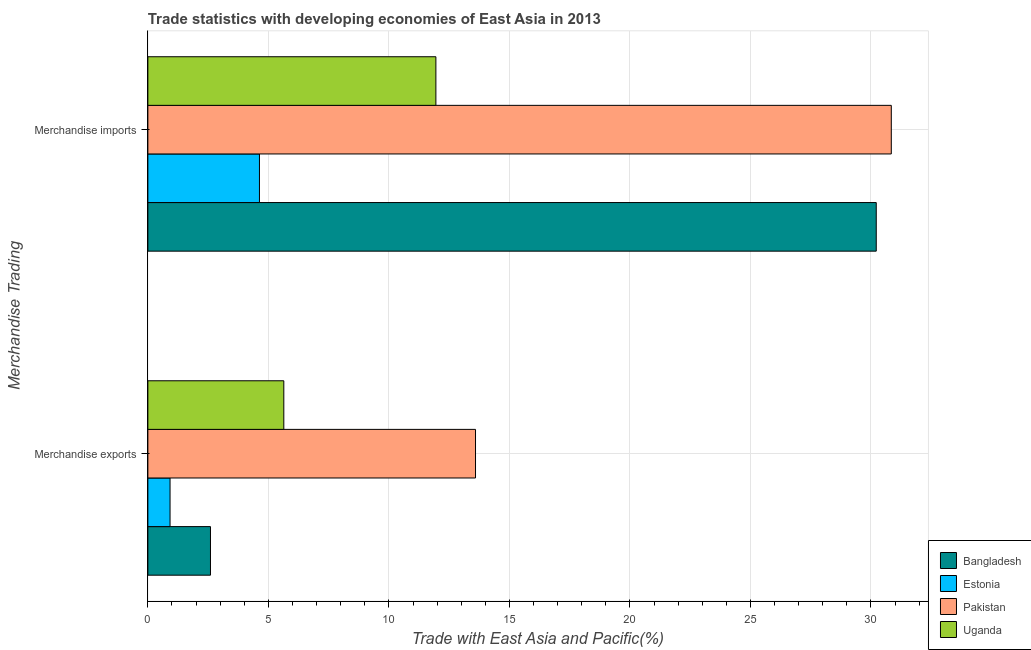How many different coloured bars are there?
Provide a succinct answer. 4. Are the number of bars per tick equal to the number of legend labels?
Ensure brevity in your answer.  Yes. How many bars are there on the 1st tick from the bottom?
Offer a terse response. 4. What is the label of the 1st group of bars from the top?
Make the answer very short. Merchandise imports. What is the merchandise imports in Pakistan?
Your answer should be very brief. 30.84. Across all countries, what is the maximum merchandise imports?
Provide a short and direct response. 30.84. Across all countries, what is the minimum merchandise imports?
Offer a terse response. 4.63. In which country was the merchandise exports minimum?
Ensure brevity in your answer.  Estonia. What is the total merchandise exports in the graph?
Make the answer very short. 22.75. What is the difference between the merchandise imports in Estonia and that in Pakistan?
Your response must be concise. -26.21. What is the difference between the merchandise exports in Uganda and the merchandise imports in Estonia?
Offer a terse response. 1.01. What is the average merchandise exports per country?
Give a very brief answer. 5.69. What is the difference between the merchandise imports and merchandise exports in Pakistan?
Your answer should be compact. 17.25. In how many countries, is the merchandise imports greater than 7 %?
Provide a short and direct response. 3. What is the ratio of the merchandise imports in Uganda to that in Bangladesh?
Ensure brevity in your answer.  0.4. What does the 2nd bar from the bottom in Merchandise imports represents?
Give a very brief answer. Estonia. How many bars are there?
Provide a short and direct response. 8. How many countries are there in the graph?
Make the answer very short. 4. What is the difference between two consecutive major ticks on the X-axis?
Your answer should be compact. 5. Are the values on the major ticks of X-axis written in scientific E-notation?
Offer a very short reply. No. Does the graph contain grids?
Offer a very short reply. Yes. What is the title of the graph?
Offer a terse response. Trade statistics with developing economies of East Asia in 2013. Does "Virgin Islands" appear as one of the legend labels in the graph?
Provide a short and direct response. No. What is the label or title of the X-axis?
Give a very brief answer. Trade with East Asia and Pacific(%). What is the label or title of the Y-axis?
Give a very brief answer. Merchandise Trading. What is the Trade with East Asia and Pacific(%) in Bangladesh in Merchandise exports?
Your answer should be very brief. 2.6. What is the Trade with East Asia and Pacific(%) in Estonia in Merchandise exports?
Provide a short and direct response. 0.92. What is the Trade with East Asia and Pacific(%) in Pakistan in Merchandise exports?
Offer a very short reply. 13.59. What is the Trade with East Asia and Pacific(%) in Uganda in Merchandise exports?
Offer a very short reply. 5.64. What is the Trade with East Asia and Pacific(%) in Bangladesh in Merchandise imports?
Your answer should be very brief. 30.22. What is the Trade with East Asia and Pacific(%) of Estonia in Merchandise imports?
Offer a very short reply. 4.63. What is the Trade with East Asia and Pacific(%) in Pakistan in Merchandise imports?
Offer a terse response. 30.84. What is the Trade with East Asia and Pacific(%) in Uganda in Merchandise imports?
Your response must be concise. 11.95. Across all Merchandise Trading, what is the maximum Trade with East Asia and Pacific(%) in Bangladesh?
Make the answer very short. 30.22. Across all Merchandise Trading, what is the maximum Trade with East Asia and Pacific(%) in Estonia?
Your answer should be very brief. 4.63. Across all Merchandise Trading, what is the maximum Trade with East Asia and Pacific(%) of Pakistan?
Provide a short and direct response. 30.84. Across all Merchandise Trading, what is the maximum Trade with East Asia and Pacific(%) in Uganda?
Offer a terse response. 11.95. Across all Merchandise Trading, what is the minimum Trade with East Asia and Pacific(%) of Bangladesh?
Offer a terse response. 2.6. Across all Merchandise Trading, what is the minimum Trade with East Asia and Pacific(%) in Estonia?
Your response must be concise. 0.92. Across all Merchandise Trading, what is the minimum Trade with East Asia and Pacific(%) in Pakistan?
Give a very brief answer. 13.59. Across all Merchandise Trading, what is the minimum Trade with East Asia and Pacific(%) in Uganda?
Your response must be concise. 5.64. What is the total Trade with East Asia and Pacific(%) in Bangladesh in the graph?
Your answer should be compact. 32.82. What is the total Trade with East Asia and Pacific(%) of Estonia in the graph?
Offer a terse response. 5.55. What is the total Trade with East Asia and Pacific(%) of Pakistan in the graph?
Offer a very short reply. 44.44. What is the total Trade with East Asia and Pacific(%) of Uganda in the graph?
Provide a succinct answer. 17.59. What is the difference between the Trade with East Asia and Pacific(%) in Bangladesh in Merchandise exports and that in Merchandise imports?
Offer a terse response. -27.62. What is the difference between the Trade with East Asia and Pacific(%) of Estonia in Merchandise exports and that in Merchandise imports?
Offer a very short reply. -3.71. What is the difference between the Trade with East Asia and Pacific(%) of Pakistan in Merchandise exports and that in Merchandise imports?
Your response must be concise. -17.25. What is the difference between the Trade with East Asia and Pacific(%) in Uganda in Merchandise exports and that in Merchandise imports?
Your answer should be very brief. -6.31. What is the difference between the Trade with East Asia and Pacific(%) of Bangladesh in Merchandise exports and the Trade with East Asia and Pacific(%) of Estonia in Merchandise imports?
Your response must be concise. -2.03. What is the difference between the Trade with East Asia and Pacific(%) in Bangladesh in Merchandise exports and the Trade with East Asia and Pacific(%) in Pakistan in Merchandise imports?
Offer a terse response. -28.24. What is the difference between the Trade with East Asia and Pacific(%) of Bangladesh in Merchandise exports and the Trade with East Asia and Pacific(%) of Uganda in Merchandise imports?
Your answer should be very brief. -9.35. What is the difference between the Trade with East Asia and Pacific(%) of Estonia in Merchandise exports and the Trade with East Asia and Pacific(%) of Pakistan in Merchandise imports?
Keep it short and to the point. -29.92. What is the difference between the Trade with East Asia and Pacific(%) of Estonia in Merchandise exports and the Trade with East Asia and Pacific(%) of Uganda in Merchandise imports?
Provide a short and direct response. -11.03. What is the difference between the Trade with East Asia and Pacific(%) of Pakistan in Merchandise exports and the Trade with East Asia and Pacific(%) of Uganda in Merchandise imports?
Ensure brevity in your answer.  1.64. What is the average Trade with East Asia and Pacific(%) in Bangladesh per Merchandise Trading?
Offer a terse response. 16.41. What is the average Trade with East Asia and Pacific(%) of Estonia per Merchandise Trading?
Provide a short and direct response. 2.77. What is the average Trade with East Asia and Pacific(%) in Pakistan per Merchandise Trading?
Ensure brevity in your answer.  22.22. What is the average Trade with East Asia and Pacific(%) of Uganda per Merchandise Trading?
Provide a short and direct response. 8.79. What is the difference between the Trade with East Asia and Pacific(%) in Bangladesh and Trade with East Asia and Pacific(%) in Estonia in Merchandise exports?
Make the answer very short. 1.68. What is the difference between the Trade with East Asia and Pacific(%) in Bangladesh and Trade with East Asia and Pacific(%) in Pakistan in Merchandise exports?
Offer a very short reply. -11. What is the difference between the Trade with East Asia and Pacific(%) in Bangladesh and Trade with East Asia and Pacific(%) in Uganda in Merchandise exports?
Offer a terse response. -3.04. What is the difference between the Trade with East Asia and Pacific(%) in Estonia and Trade with East Asia and Pacific(%) in Pakistan in Merchandise exports?
Give a very brief answer. -12.67. What is the difference between the Trade with East Asia and Pacific(%) in Estonia and Trade with East Asia and Pacific(%) in Uganda in Merchandise exports?
Your answer should be very brief. -4.72. What is the difference between the Trade with East Asia and Pacific(%) in Pakistan and Trade with East Asia and Pacific(%) in Uganda in Merchandise exports?
Your answer should be compact. 7.95. What is the difference between the Trade with East Asia and Pacific(%) in Bangladesh and Trade with East Asia and Pacific(%) in Estonia in Merchandise imports?
Make the answer very short. 25.59. What is the difference between the Trade with East Asia and Pacific(%) in Bangladesh and Trade with East Asia and Pacific(%) in Pakistan in Merchandise imports?
Offer a very short reply. -0.62. What is the difference between the Trade with East Asia and Pacific(%) of Bangladesh and Trade with East Asia and Pacific(%) of Uganda in Merchandise imports?
Provide a succinct answer. 18.27. What is the difference between the Trade with East Asia and Pacific(%) of Estonia and Trade with East Asia and Pacific(%) of Pakistan in Merchandise imports?
Offer a very short reply. -26.21. What is the difference between the Trade with East Asia and Pacific(%) of Estonia and Trade with East Asia and Pacific(%) of Uganda in Merchandise imports?
Offer a terse response. -7.32. What is the difference between the Trade with East Asia and Pacific(%) of Pakistan and Trade with East Asia and Pacific(%) of Uganda in Merchandise imports?
Your answer should be compact. 18.89. What is the ratio of the Trade with East Asia and Pacific(%) in Bangladesh in Merchandise exports to that in Merchandise imports?
Your answer should be compact. 0.09. What is the ratio of the Trade with East Asia and Pacific(%) of Estonia in Merchandise exports to that in Merchandise imports?
Your response must be concise. 0.2. What is the ratio of the Trade with East Asia and Pacific(%) in Pakistan in Merchandise exports to that in Merchandise imports?
Ensure brevity in your answer.  0.44. What is the ratio of the Trade with East Asia and Pacific(%) in Uganda in Merchandise exports to that in Merchandise imports?
Provide a succinct answer. 0.47. What is the difference between the highest and the second highest Trade with East Asia and Pacific(%) in Bangladesh?
Your answer should be very brief. 27.62. What is the difference between the highest and the second highest Trade with East Asia and Pacific(%) in Estonia?
Offer a very short reply. 3.71. What is the difference between the highest and the second highest Trade with East Asia and Pacific(%) of Pakistan?
Ensure brevity in your answer.  17.25. What is the difference between the highest and the second highest Trade with East Asia and Pacific(%) in Uganda?
Give a very brief answer. 6.31. What is the difference between the highest and the lowest Trade with East Asia and Pacific(%) of Bangladesh?
Ensure brevity in your answer.  27.62. What is the difference between the highest and the lowest Trade with East Asia and Pacific(%) of Estonia?
Make the answer very short. 3.71. What is the difference between the highest and the lowest Trade with East Asia and Pacific(%) in Pakistan?
Provide a succinct answer. 17.25. What is the difference between the highest and the lowest Trade with East Asia and Pacific(%) of Uganda?
Offer a terse response. 6.31. 